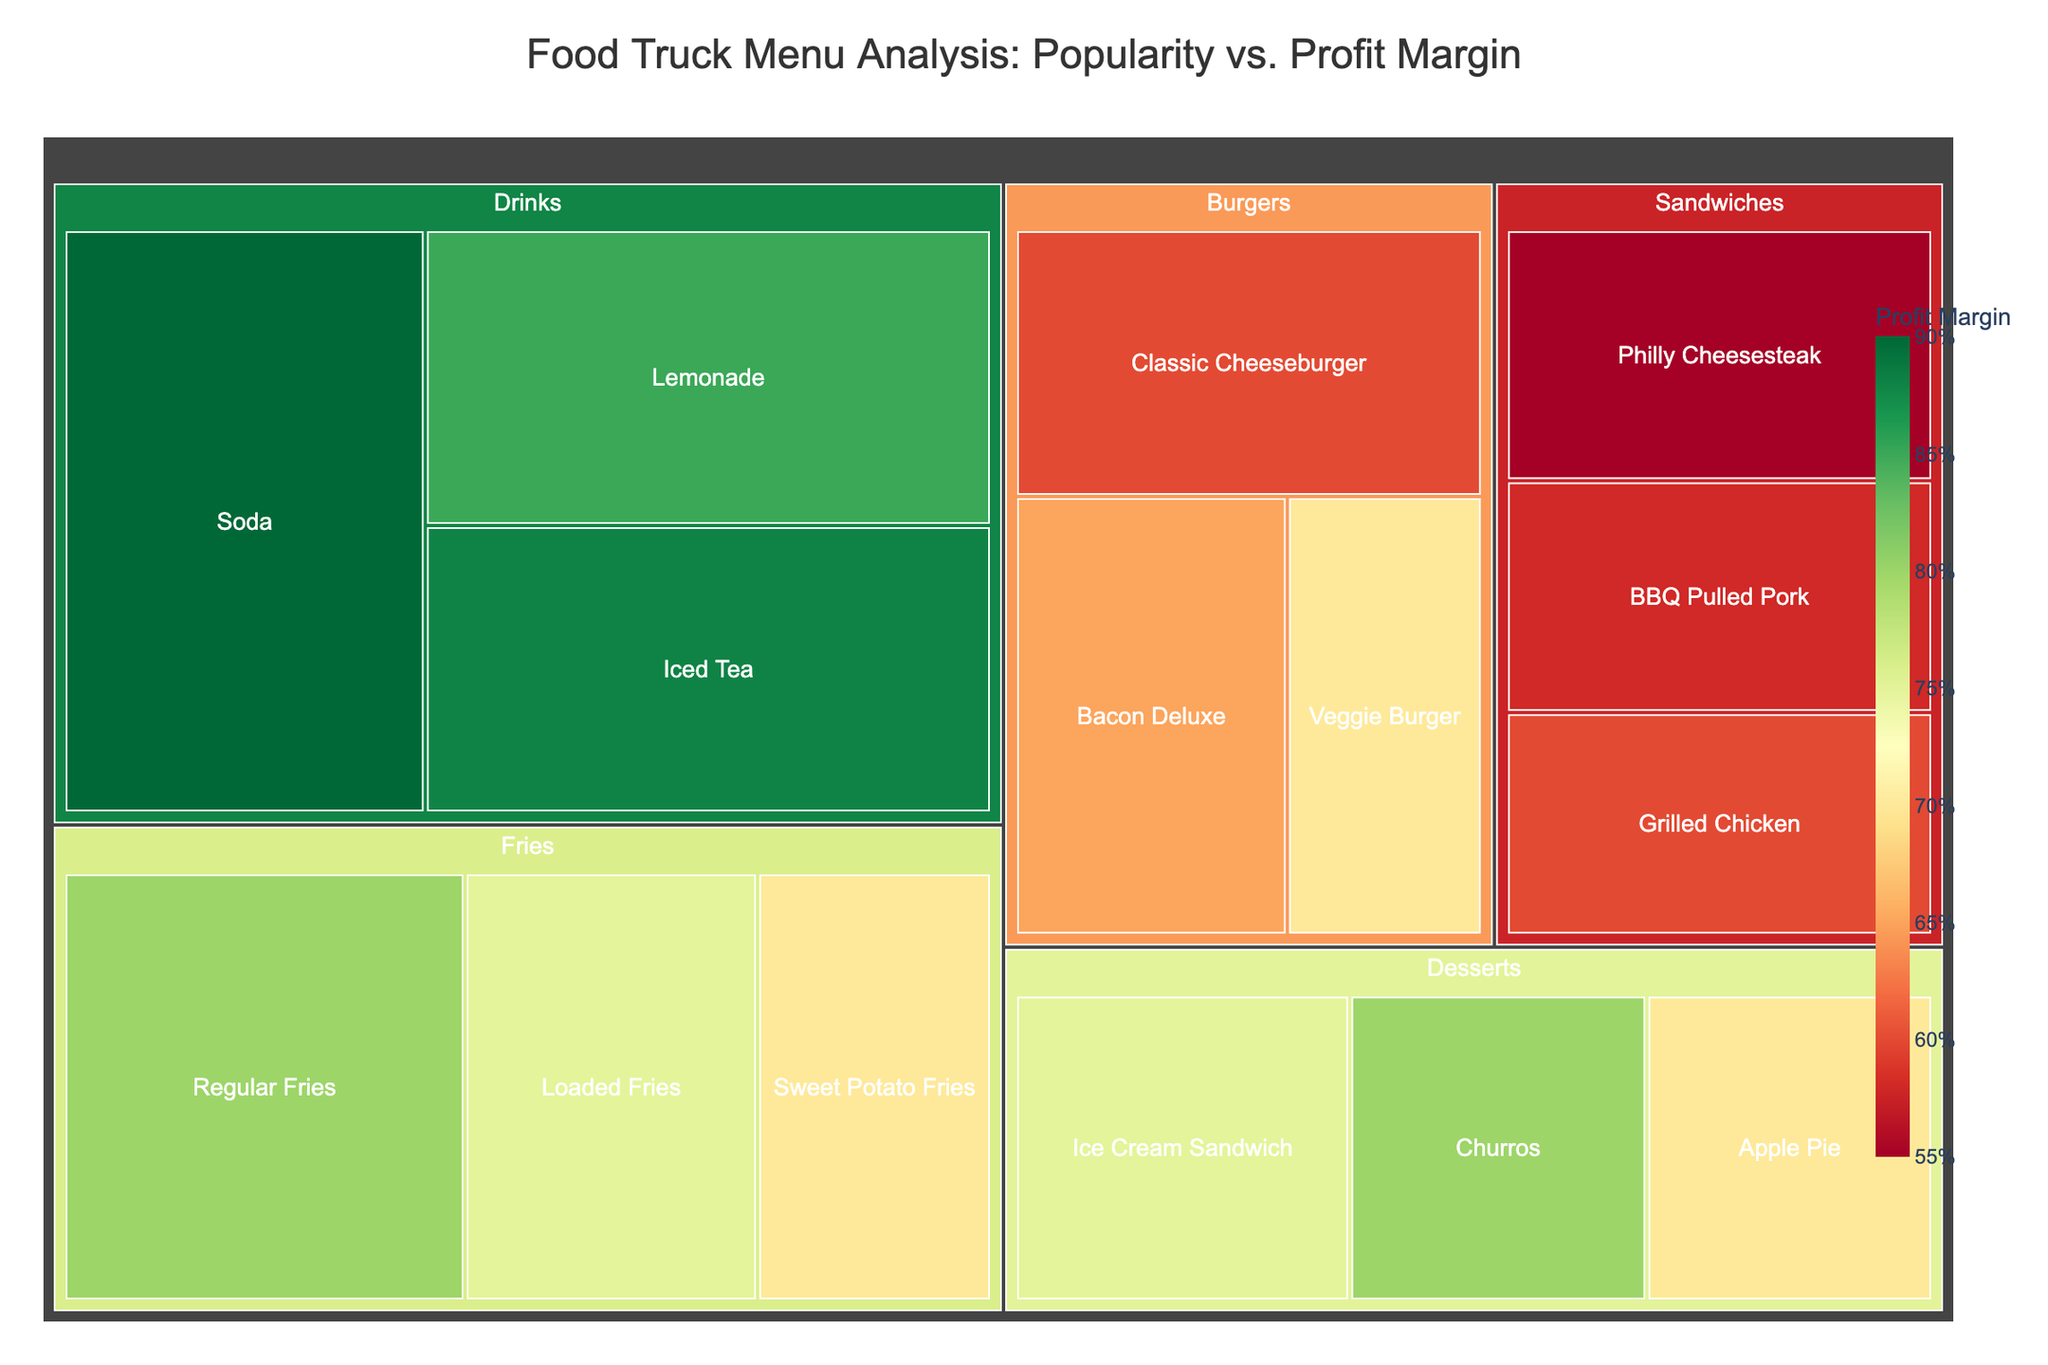What is the title of the treemap? The title is usually located at the top of the figure and provides a summary of what the chart represents.
Answer: Food Truck Menu Analysis: Popularity vs. Profit Margin Which item in the 'Drinks' category has the highest popularity? Look at the section labeled 'Drinks' and identify the item that is visually the largest since the area represents the product of popularity and profit margin. Hovering over each item can also show exact popularity values.
Answer: Soda How does the profit margin of the 'Loaded Fries' compare to 'Regular Fries'? Inspect the 'Fries' category and note the color of each item to determine their relative profit margins. 'Regular Fries' will have a higher because the profit margins are color-coded with a continuous scale where greener indicates higher margins.
Answer: Regular Fries have a higher profit margin What is the combined popularity of all items in the 'Sandwiches' category? Sum the popularity values of 'Philly Cheesesteak', 'Grilled Chicken', and 'BBQ Pulled Pork', which are all in the 'Sandwiches' group.
Answer: 215 Which category has the lowest average profit margin? Average the profit margins of each item within each category and compare them.
Answer: Sandwiches What is the visual appearance used to represent different profit margins? Notice the color coding of the items, where different shades represent different profit margins.
Answer: Different colors, with greener shades indicating higher profit margins How many items are there in the 'Desserts' category? Count the distinct items clearly labeled under the 'Desserts' category within the plot.
Answer: 3 Which burger item has the highest profit margin? Within the 'Burgers' category, look for the item with the most green shading, indicating the highest profit margin.
Answer: Veggie Burger If you prioritize items by their contribution to both popularity and profit, which dessert item should you focus on first? Compare each dessert's size within the treemap, as size represents a combination of popularity and profit margin.
Answer: Ice Cream Sandwich What is the relative size of 'Iced Tea' in the 'Drinks' category compared to 'Lemonade'? Assess the visual area of both 'Iced Tea' and 'Lemonade'; 'Lemonade' should be larger due to its higher combined popularity and profit margin.
Answer: 'Lemonade' is larger than 'Iced Tea' 